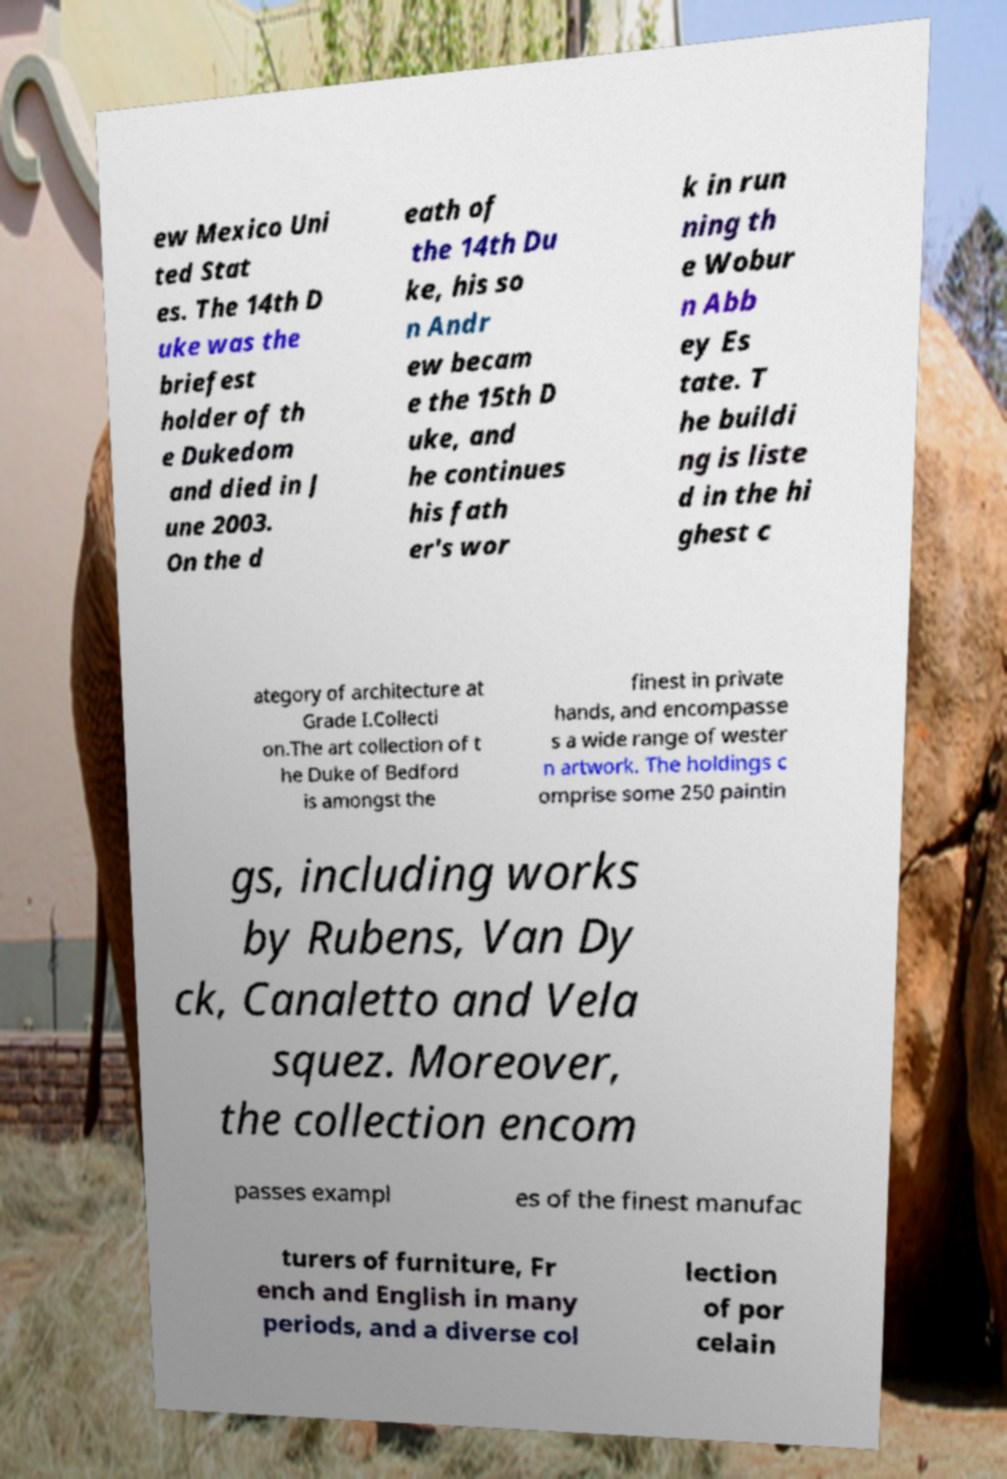I need the written content from this picture converted into text. Can you do that? ew Mexico Uni ted Stat es. The 14th D uke was the briefest holder of th e Dukedom and died in J une 2003. On the d eath of the 14th Du ke, his so n Andr ew becam e the 15th D uke, and he continues his fath er's wor k in run ning th e Wobur n Abb ey Es tate. T he buildi ng is liste d in the hi ghest c ategory of architecture at Grade I.Collecti on.The art collection of t he Duke of Bedford is amongst the finest in private hands, and encompasse s a wide range of wester n artwork. The holdings c omprise some 250 paintin gs, including works by Rubens, Van Dy ck, Canaletto and Vela squez. Moreover, the collection encom passes exampl es of the finest manufac turers of furniture, Fr ench and English in many periods, and a diverse col lection of por celain 